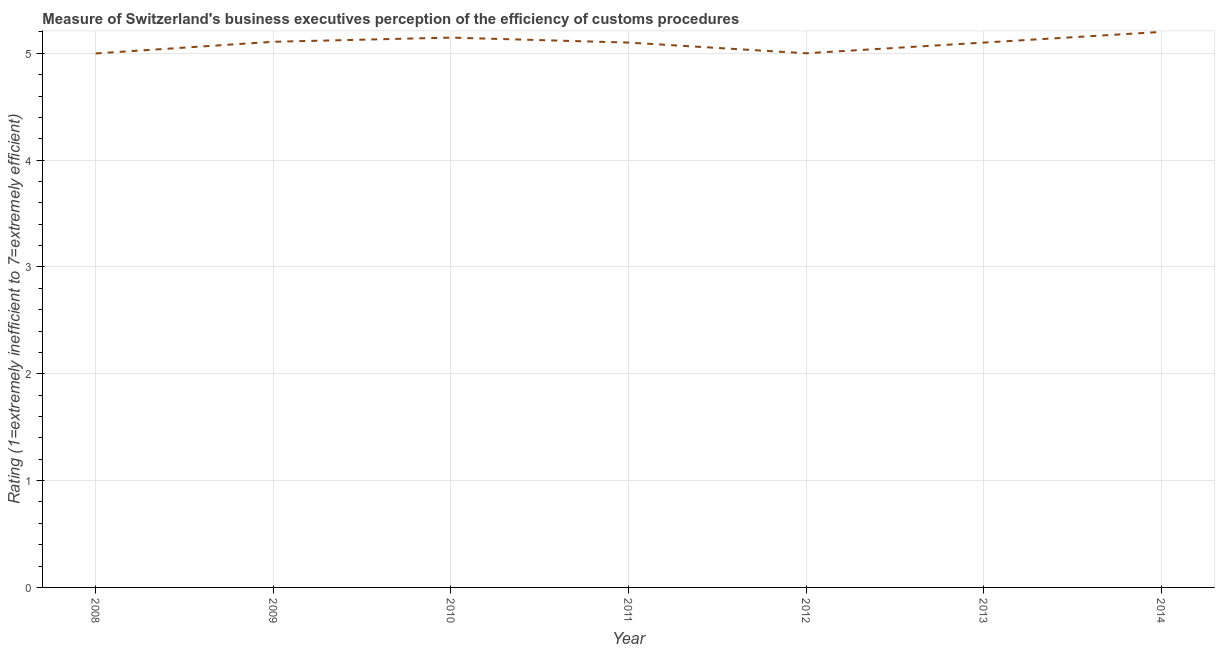What is the rating measuring burden of customs procedure in 2008?
Your answer should be very brief. 5. Across all years, what is the maximum rating measuring burden of customs procedure?
Provide a succinct answer. 5.2. Across all years, what is the minimum rating measuring burden of customs procedure?
Ensure brevity in your answer.  5. In which year was the rating measuring burden of customs procedure maximum?
Make the answer very short. 2014. What is the sum of the rating measuring burden of customs procedure?
Your response must be concise. 35.65. What is the difference between the rating measuring burden of customs procedure in 2013 and 2014?
Keep it short and to the point. -0.1. What is the average rating measuring burden of customs procedure per year?
Ensure brevity in your answer.  5.09. Do a majority of the years between 2013 and 2011 (inclusive) have rating measuring burden of customs procedure greater than 3 ?
Your answer should be compact. No. What is the ratio of the rating measuring burden of customs procedure in 2010 to that in 2014?
Ensure brevity in your answer.  0.99. Is the difference between the rating measuring burden of customs procedure in 2013 and 2014 greater than the difference between any two years?
Ensure brevity in your answer.  No. What is the difference between the highest and the second highest rating measuring burden of customs procedure?
Give a very brief answer. 0.05. What is the difference between the highest and the lowest rating measuring burden of customs procedure?
Your answer should be compact. 0.2. Does the rating measuring burden of customs procedure monotonically increase over the years?
Make the answer very short. No. How many years are there in the graph?
Ensure brevity in your answer.  7. What is the difference between two consecutive major ticks on the Y-axis?
Your answer should be very brief. 1. Are the values on the major ticks of Y-axis written in scientific E-notation?
Provide a succinct answer. No. Does the graph contain any zero values?
Offer a terse response. No. Does the graph contain grids?
Your answer should be compact. Yes. What is the title of the graph?
Provide a short and direct response. Measure of Switzerland's business executives perception of the efficiency of customs procedures. What is the label or title of the X-axis?
Your response must be concise. Year. What is the label or title of the Y-axis?
Give a very brief answer. Rating (1=extremely inefficient to 7=extremely efficient). What is the Rating (1=extremely inefficient to 7=extremely efficient) in 2008?
Provide a succinct answer. 5. What is the Rating (1=extremely inefficient to 7=extremely efficient) of 2009?
Offer a very short reply. 5.11. What is the Rating (1=extremely inefficient to 7=extremely efficient) in 2010?
Your answer should be compact. 5.15. What is the Rating (1=extremely inefficient to 7=extremely efficient) in 2011?
Offer a terse response. 5.1. What is the Rating (1=extremely inefficient to 7=extremely efficient) in 2012?
Keep it short and to the point. 5. What is the Rating (1=extremely inefficient to 7=extremely efficient) in 2013?
Keep it short and to the point. 5.1. What is the Rating (1=extremely inefficient to 7=extremely efficient) in 2014?
Offer a very short reply. 5.2. What is the difference between the Rating (1=extremely inefficient to 7=extremely efficient) in 2008 and 2009?
Your answer should be compact. -0.11. What is the difference between the Rating (1=extremely inefficient to 7=extremely efficient) in 2008 and 2010?
Your response must be concise. -0.15. What is the difference between the Rating (1=extremely inefficient to 7=extremely efficient) in 2008 and 2011?
Your answer should be compact. -0.1. What is the difference between the Rating (1=extremely inefficient to 7=extremely efficient) in 2008 and 2012?
Keep it short and to the point. -0. What is the difference between the Rating (1=extremely inefficient to 7=extremely efficient) in 2008 and 2013?
Your answer should be very brief. -0.1. What is the difference between the Rating (1=extremely inefficient to 7=extremely efficient) in 2008 and 2014?
Make the answer very short. -0.2. What is the difference between the Rating (1=extremely inefficient to 7=extremely efficient) in 2009 and 2010?
Your answer should be compact. -0.04. What is the difference between the Rating (1=extremely inefficient to 7=extremely efficient) in 2009 and 2011?
Give a very brief answer. 0.01. What is the difference between the Rating (1=extremely inefficient to 7=extremely efficient) in 2009 and 2012?
Offer a very short reply. 0.11. What is the difference between the Rating (1=extremely inefficient to 7=extremely efficient) in 2009 and 2013?
Keep it short and to the point. 0.01. What is the difference between the Rating (1=extremely inefficient to 7=extremely efficient) in 2009 and 2014?
Provide a short and direct response. -0.09. What is the difference between the Rating (1=extremely inefficient to 7=extremely efficient) in 2010 and 2011?
Offer a terse response. 0.05. What is the difference between the Rating (1=extremely inefficient to 7=extremely efficient) in 2010 and 2012?
Give a very brief answer. 0.15. What is the difference between the Rating (1=extremely inefficient to 7=extremely efficient) in 2010 and 2013?
Provide a succinct answer. 0.05. What is the difference between the Rating (1=extremely inefficient to 7=extremely efficient) in 2010 and 2014?
Give a very brief answer. -0.05. What is the difference between the Rating (1=extremely inefficient to 7=extremely efficient) in 2011 and 2012?
Ensure brevity in your answer.  0.1. What is the difference between the Rating (1=extremely inefficient to 7=extremely efficient) in 2013 and 2014?
Provide a succinct answer. -0.1. What is the ratio of the Rating (1=extremely inefficient to 7=extremely efficient) in 2008 to that in 2009?
Ensure brevity in your answer.  0.98. What is the ratio of the Rating (1=extremely inefficient to 7=extremely efficient) in 2008 to that in 2010?
Your answer should be very brief. 0.97. What is the ratio of the Rating (1=extremely inefficient to 7=extremely efficient) in 2008 to that in 2011?
Give a very brief answer. 0.98. What is the ratio of the Rating (1=extremely inefficient to 7=extremely efficient) in 2008 to that in 2012?
Give a very brief answer. 1. What is the ratio of the Rating (1=extremely inefficient to 7=extremely efficient) in 2009 to that in 2011?
Give a very brief answer. 1. What is the ratio of the Rating (1=extremely inefficient to 7=extremely efficient) in 2009 to that in 2012?
Ensure brevity in your answer.  1.02. What is the ratio of the Rating (1=extremely inefficient to 7=extremely efficient) in 2009 to that in 2013?
Keep it short and to the point. 1. What is the ratio of the Rating (1=extremely inefficient to 7=extremely efficient) in 2009 to that in 2014?
Keep it short and to the point. 0.98. What is the ratio of the Rating (1=extremely inefficient to 7=extremely efficient) in 2010 to that in 2012?
Your answer should be compact. 1.03. What is the ratio of the Rating (1=extremely inefficient to 7=extremely efficient) in 2010 to that in 2013?
Provide a succinct answer. 1.01. What is the ratio of the Rating (1=extremely inefficient to 7=extremely efficient) in 2011 to that in 2012?
Your response must be concise. 1.02. What is the ratio of the Rating (1=extremely inefficient to 7=extremely efficient) in 2011 to that in 2013?
Ensure brevity in your answer.  1. What is the ratio of the Rating (1=extremely inefficient to 7=extremely efficient) in 2012 to that in 2013?
Your answer should be very brief. 0.98. What is the ratio of the Rating (1=extremely inefficient to 7=extremely efficient) in 2013 to that in 2014?
Ensure brevity in your answer.  0.98. 